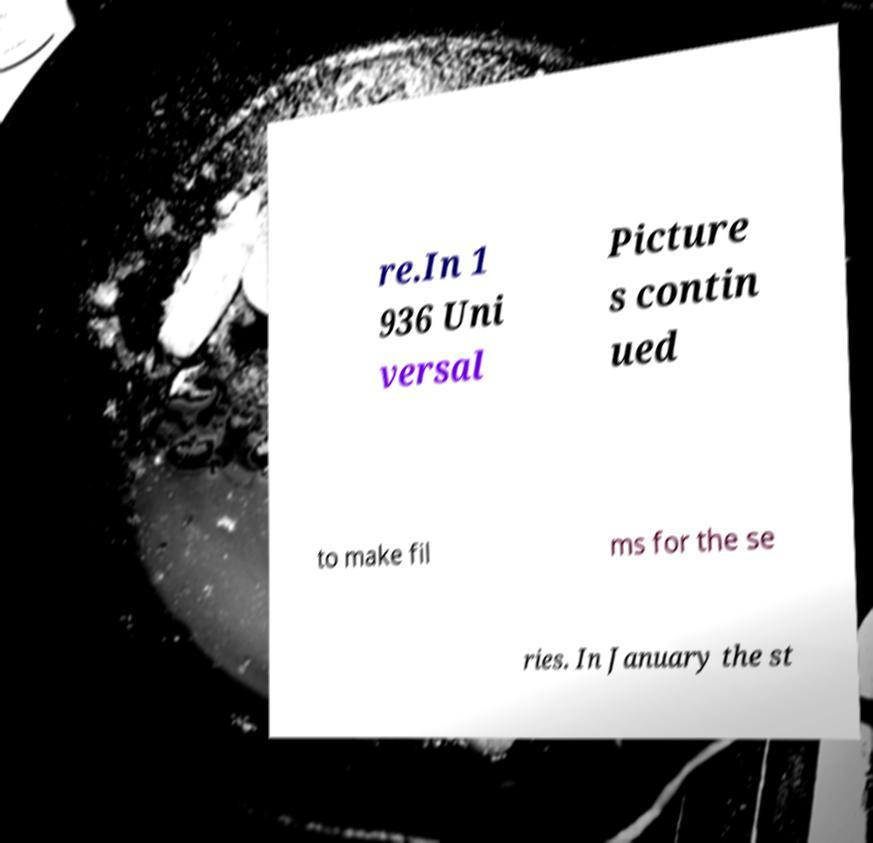Please read and relay the text visible in this image. What does it say? re.In 1 936 Uni versal Picture s contin ued to make fil ms for the se ries. In January the st 